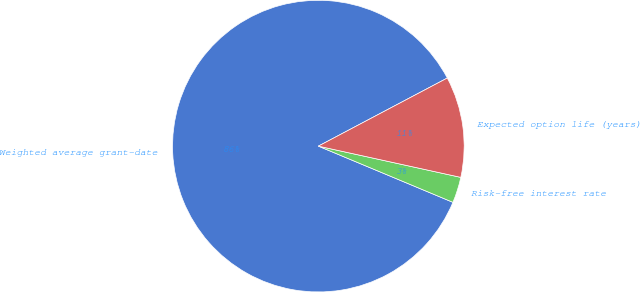Convert chart. <chart><loc_0><loc_0><loc_500><loc_500><pie_chart><fcel>Weighted average grant-date<fcel>Risk-free interest rate<fcel>Expected option life (years)<nl><fcel>85.97%<fcel>2.86%<fcel>11.17%<nl></chart> 